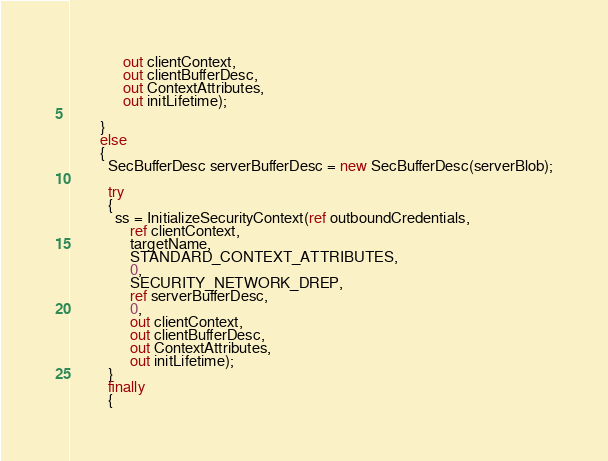<code> <loc_0><loc_0><loc_500><loc_500><_C#_>              out clientContext,
              out clientBufferDesc,
              out ContextAttributes,
              out initLifetime);

        }
        else
        {
          SecBufferDesc serverBufferDesc = new SecBufferDesc(serverBlob);

          try
          {
            ss = InitializeSecurityContext(ref outboundCredentials,
                ref clientContext,
                targetName,
                STANDARD_CONTEXT_ATTRIBUTES,
                0,
                SECURITY_NETWORK_DREP,
                ref serverBufferDesc,
                0,
                out clientContext,
                out clientBufferDesc,
                out ContextAttributes,
                out initLifetime);
          }
          finally
          {</code> 